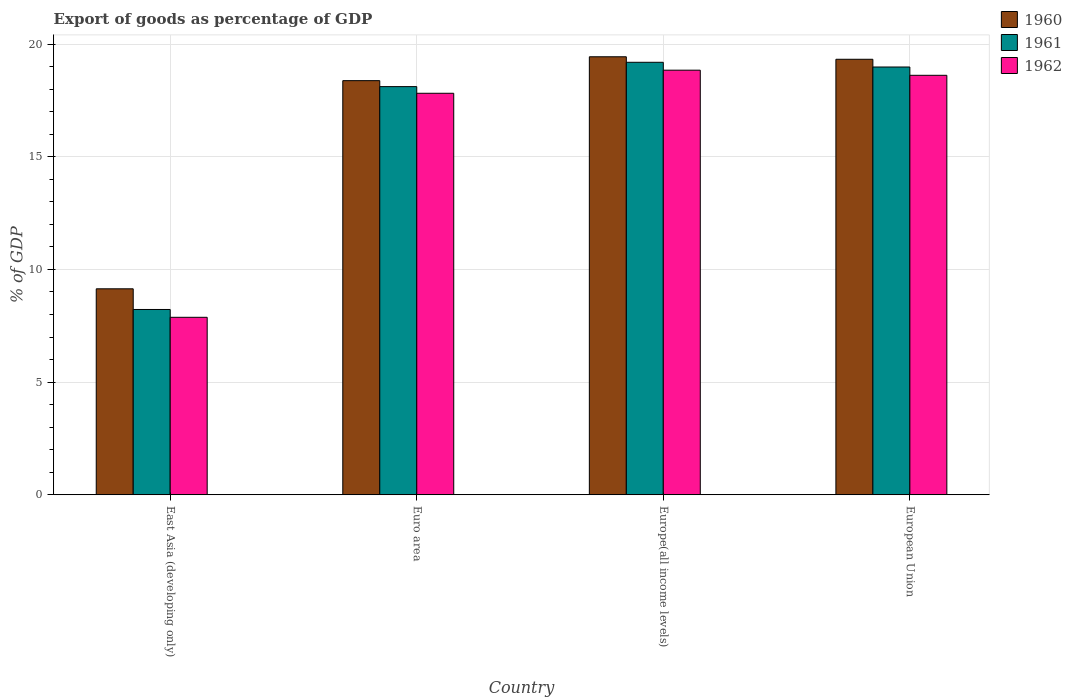How many different coloured bars are there?
Your answer should be very brief. 3. How many groups of bars are there?
Make the answer very short. 4. Are the number of bars per tick equal to the number of legend labels?
Give a very brief answer. Yes. What is the label of the 1st group of bars from the left?
Your response must be concise. East Asia (developing only). What is the export of goods as percentage of GDP in 1962 in European Union?
Make the answer very short. 18.61. Across all countries, what is the maximum export of goods as percentage of GDP in 1961?
Your response must be concise. 19.19. Across all countries, what is the minimum export of goods as percentage of GDP in 1961?
Offer a very short reply. 8.22. In which country was the export of goods as percentage of GDP in 1962 maximum?
Your response must be concise. Europe(all income levels). In which country was the export of goods as percentage of GDP in 1962 minimum?
Give a very brief answer. East Asia (developing only). What is the total export of goods as percentage of GDP in 1960 in the graph?
Your answer should be compact. 66.28. What is the difference between the export of goods as percentage of GDP in 1962 in East Asia (developing only) and that in Euro area?
Provide a succinct answer. -9.94. What is the difference between the export of goods as percentage of GDP in 1962 in Europe(all income levels) and the export of goods as percentage of GDP in 1961 in East Asia (developing only)?
Keep it short and to the point. 10.62. What is the average export of goods as percentage of GDP in 1960 per country?
Offer a very short reply. 16.57. What is the difference between the export of goods as percentage of GDP of/in 1962 and export of goods as percentage of GDP of/in 1961 in Europe(all income levels)?
Offer a terse response. -0.35. In how many countries, is the export of goods as percentage of GDP in 1960 greater than 14 %?
Keep it short and to the point. 3. What is the ratio of the export of goods as percentage of GDP in 1962 in Euro area to that in Europe(all income levels)?
Ensure brevity in your answer.  0.95. What is the difference between the highest and the second highest export of goods as percentage of GDP in 1962?
Keep it short and to the point. -1.03. What is the difference between the highest and the lowest export of goods as percentage of GDP in 1960?
Offer a very short reply. 10.3. Is the sum of the export of goods as percentage of GDP in 1960 in East Asia (developing only) and Euro area greater than the maximum export of goods as percentage of GDP in 1962 across all countries?
Offer a very short reply. Yes. What does the 3rd bar from the left in Europe(all income levels) represents?
Ensure brevity in your answer.  1962. How many bars are there?
Your answer should be compact. 12. How many countries are there in the graph?
Keep it short and to the point. 4. Does the graph contain grids?
Provide a short and direct response. Yes. How are the legend labels stacked?
Offer a terse response. Vertical. What is the title of the graph?
Offer a terse response. Export of goods as percentage of GDP. Does "1996" appear as one of the legend labels in the graph?
Give a very brief answer. No. What is the label or title of the Y-axis?
Offer a terse response. % of GDP. What is the % of GDP of 1960 in East Asia (developing only)?
Provide a short and direct response. 9.14. What is the % of GDP in 1961 in East Asia (developing only)?
Provide a short and direct response. 8.22. What is the % of GDP of 1962 in East Asia (developing only)?
Make the answer very short. 7.88. What is the % of GDP in 1960 in Euro area?
Offer a terse response. 18.38. What is the % of GDP in 1961 in Euro area?
Provide a succinct answer. 18.11. What is the % of GDP in 1962 in Euro area?
Your answer should be very brief. 17.82. What is the % of GDP in 1960 in Europe(all income levels)?
Make the answer very short. 19.44. What is the % of GDP of 1961 in Europe(all income levels)?
Your answer should be compact. 19.19. What is the % of GDP of 1962 in Europe(all income levels)?
Your answer should be very brief. 18.84. What is the % of GDP of 1960 in European Union?
Offer a very short reply. 19.33. What is the % of GDP of 1961 in European Union?
Your answer should be compact. 18.98. What is the % of GDP in 1962 in European Union?
Your answer should be compact. 18.61. Across all countries, what is the maximum % of GDP of 1960?
Provide a short and direct response. 19.44. Across all countries, what is the maximum % of GDP of 1961?
Your answer should be very brief. 19.19. Across all countries, what is the maximum % of GDP of 1962?
Give a very brief answer. 18.84. Across all countries, what is the minimum % of GDP of 1960?
Provide a succinct answer. 9.14. Across all countries, what is the minimum % of GDP of 1961?
Keep it short and to the point. 8.22. Across all countries, what is the minimum % of GDP in 1962?
Your answer should be very brief. 7.88. What is the total % of GDP of 1960 in the graph?
Make the answer very short. 66.28. What is the total % of GDP in 1961 in the graph?
Your answer should be compact. 64.51. What is the total % of GDP in 1962 in the graph?
Provide a short and direct response. 63.15. What is the difference between the % of GDP of 1960 in East Asia (developing only) and that in Euro area?
Offer a terse response. -9.24. What is the difference between the % of GDP of 1961 in East Asia (developing only) and that in Euro area?
Provide a succinct answer. -9.89. What is the difference between the % of GDP of 1962 in East Asia (developing only) and that in Euro area?
Ensure brevity in your answer.  -9.94. What is the difference between the % of GDP in 1960 in East Asia (developing only) and that in Europe(all income levels)?
Your answer should be compact. -10.3. What is the difference between the % of GDP of 1961 in East Asia (developing only) and that in Europe(all income levels)?
Keep it short and to the point. -10.97. What is the difference between the % of GDP in 1962 in East Asia (developing only) and that in Europe(all income levels)?
Ensure brevity in your answer.  -10.97. What is the difference between the % of GDP of 1960 in East Asia (developing only) and that in European Union?
Make the answer very short. -10.19. What is the difference between the % of GDP of 1961 in East Asia (developing only) and that in European Union?
Your answer should be very brief. -10.76. What is the difference between the % of GDP in 1962 in East Asia (developing only) and that in European Union?
Your response must be concise. -10.74. What is the difference between the % of GDP in 1960 in Euro area and that in Europe(all income levels)?
Keep it short and to the point. -1.06. What is the difference between the % of GDP of 1961 in Euro area and that in Europe(all income levels)?
Your response must be concise. -1.08. What is the difference between the % of GDP in 1962 in Euro area and that in Europe(all income levels)?
Make the answer very short. -1.03. What is the difference between the % of GDP of 1960 in Euro area and that in European Union?
Make the answer very short. -0.95. What is the difference between the % of GDP in 1961 in Euro area and that in European Union?
Make the answer very short. -0.87. What is the difference between the % of GDP of 1962 in Euro area and that in European Union?
Your answer should be compact. -0.8. What is the difference between the % of GDP of 1960 in Europe(all income levels) and that in European Union?
Provide a succinct answer. 0.11. What is the difference between the % of GDP in 1961 in Europe(all income levels) and that in European Union?
Your answer should be compact. 0.21. What is the difference between the % of GDP in 1962 in Europe(all income levels) and that in European Union?
Keep it short and to the point. 0.23. What is the difference between the % of GDP in 1960 in East Asia (developing only) and the % of GDP in 1961 in Euro area?
Offer a terse response. -8.97. What is the difference between the % of GDP of 1960 in East Asia (developing only) and the % of GDP of 1962 in Euro area?
Your response must be concise. -8.68. What is the difference between the % of GDP of 1961 in East Asia (developing only) and the % of GDP of 1962 in Euro area?
Offer a terse response. -9.59. What is the difference between the % of GDP of 1960 in East Asia (developing only) and the % of GDP of 1961 in Europe(all income levels)?
Make the answer very short. -10.05. What is the difference between the % of GDP in 1960 in East Asia (developing only) and the % of GDP in 1962 in Europe(all income levels)?
Your answer should be compact. -9.7. What is the difference between the % of GDP in 1961 in East Asia (developing only) and the % of GDP in 1962 in Europe(all income levels)?
Offer a very short reply. -10.62. What is the difference between the % of GDP in 1960 in East Asia (developing only) and the % of GDP in 1961 in European Union?
Your answer should be compact. -9.84. What is the difference between the % of GDP in 1960 in East Asia (developing only) and the % of GDP in 1962 in European Union?
Your answer should be very brief. -9.47. What is the difference between the % of GDP in 1961 in East Asia (developing only) and the % of GDP in 1962 in European Union?
Provide a succinct answer. -10.39. What is the difference between the % of GDP of 1960 in Euro area and the % of GDP of 1961 in Europe(all income levels)?
Your answer should be compact. -0.81. What is the difference between the % of GDP in 1960 in Euro area and the % of GDP in 1962 in Europe(all income levels)?
Offer a very short reply. -0.46. What is the difference between the % of GDP in 1961 in Euro area and the % of GDP in 1962 in Europe(all income levels)?
Your answer should be very brief. -0.73. What is the difference between the % of GDP of 1960 in Euro area and the % of GDP of 1961 in European Union?
Ensure brevity in your answer.  -0.61. What is the difference between the % of GDP of 1960 in Euro area and the % of GDP of 1962 in European Union?
Provide a succinct answer. -0.24. What is the difference between the % of GDP in 1961 in Euro area and the % of GDP in 1962 in European Union?
Keep it short and to the point. -0.5. What is the difference between the % of GDP of 1960 in Europe(all income levels) and the % of GDP of 1961 in European Union?
Offer a terse response. 0.45. What is the difference between the % of GDP of 1960 in Europe(all income levels) and the % of GDP of 1962 in European Union?
Your answer should be compact. 0.82. What is the difference between the % of GDP of 1961 in Europe(all income levels) and the % of GDP of 1962 in European Union?
Offer a terse response. 0.58. What is the average % of GDP of 1960 per country?
Offer a very short reply. 16.57. What is the average % of GDP in 1961 per country?
Provide a succinct answer. 16.13. What is the average % of GDP in 1962 per country?
Provide a succinct answer. 15.79. What is the difference between the % of GDP of 1960 and % of GDP of 1961 in East Asia (developing only)?
Keep it short and to the point. 0.92. What is the difference between the % of GDP of 1960 and % of GDP of 1962 in East Asia (developing only)?
Give a very brief answer. 1.26. What is the difference between the % of GDP of 1961 and % of GDP of 1962 in East Asia (developing only)?
Provide a short and direct response. 0.35. What is the difference between the % of GDP in 1960 and % of GDP in 1961 in Euro area?
Your answer should be compact. 0.27. What is the difference between the % of GDP in 1960 and % of GDP in 1962 in Euro area?
Offer a very short reply. 0.56. What is the difference between the % of GDP in 1961 and % of GDP in 1962 in Euro area?
Offer a terse response. 0.3. What is the difference between the % of GDP in 1960 and % of GDP in 1961 in Europe(all income levels)?
Make the answer very short. 0.24. What is the difference between the % of GDP in 1960 and % of GDP in 1962 in Europe(all income levels)?
Give a very brief answer. 0.59. What is the difference between the % of GDP of 1961 and % of GDP of 1962 in Europe(all income levels)?
Your response must be concise. 0.35. What is the difference between the % of GDP of 1960 and % of GDP of 1961 in European Union?
Your response must be concise. 0.34. What is the difference between the % of GDP of 1960 and % of GDP of 1962 in European Union?
Provide a succinct answer. 0.71. What is the difference between the % of GDP of 1961 and % of GDP of 1962 in European Union?
Your answer should be very brief. 0.37. What is the ratio of the % of GDP in 1960 in East Asia (developing only) to that in Euro area?
Ensure brevity in your answer.  0.5. What is the ratio of the % of GDP in 1961 in East Asia (developing only) to that in Euro area?
Provide a succinct answer. 0.45. What is the ratio of the % of GDP in 1962 in East Asia (developing only) to that in Euro area?
Provide a short and direct response. 0.44. What is the ratio of the % of GDP of 1960 in East Asia (developing only) to that in Europe(all income levels)?
Provide a succinct answer. 0.47. What is the ratio of the % of GDP of 1961 in East Asia (developing only) to that in Europe(all income levels)?
Provide a short and direct response. 0.43. What is the ratio of the % of GDP of 1962 in East Asia (developing only) to that in Europe(all income levels)?
Keep it short and to the point. 0.42. What is the ratio of the % of GDP of 1960 in East Asia (developing only) to that in European Union?
Your response must be concise. 0.47. What is the ratio of the % of GDP in 1961 in East Asia (developing only) to that in European Union?
Offer a terse response. 0.43. What is the ratio of the % of GDP of 1962 in East Asia (developing only) to that in European Union?
Your answer should be very brief. 0.42. What is the ratio of the % of GDP of 1960 in Euro area to that in Europe(all income levels)?
Offer a terse response. 0.95. What is the ratio of the % of GDP in 1961 in Euro area to that in Europe(all income levels)?
Give a very brief answer. 0.94. What is the ratio of the % of GDP in 1962 in Euro area to that in Europe(all income levels)?
Give a very brief answer. 0.95. What is the ratio of the % of GDP of 1960 in Euro area to that in European Union?
Offer a very short reply. 0.95. What is the ratio of the % of GDP of 1961 in Euro area to that in European Union?
Offer a terse response. 0.95. What is the ratio of the % of GDP of 1962 in Euro area to that in European Union?
Ensure brevity in your answer.  0.96. What is the ratio of the % of GDP of 1961 in Europe(all income levels) to that in European Union?
Your answer should be very brief. 1.01. What is the ratio of the % of GDP in 1962 in Europe(all income levels) to that in European Union?
Your answer should be compact. 1.01. What is the difference between the highest and the second highest % of GDP of 1960?
Offer a terse response. 0.11. What is the difference between the highest and the second highest % of GDP in 1961?
Provide a short and direct response. 0.21. What is the difference between the highest and the second highest % of GDP in 1962?
Ensure brevity in your answer.  0.23. What is the difference between the highest and the lowest % of GDP in 1960?
Your answer should be compact. 10.3. What is the difference between the highest and the lowest % of GDP in 1961?
Provide a succinct answer. 10.97. What is the difference between the highest and the lowest % of GDP in 1962?
Your answer should be compact. 10.97. 